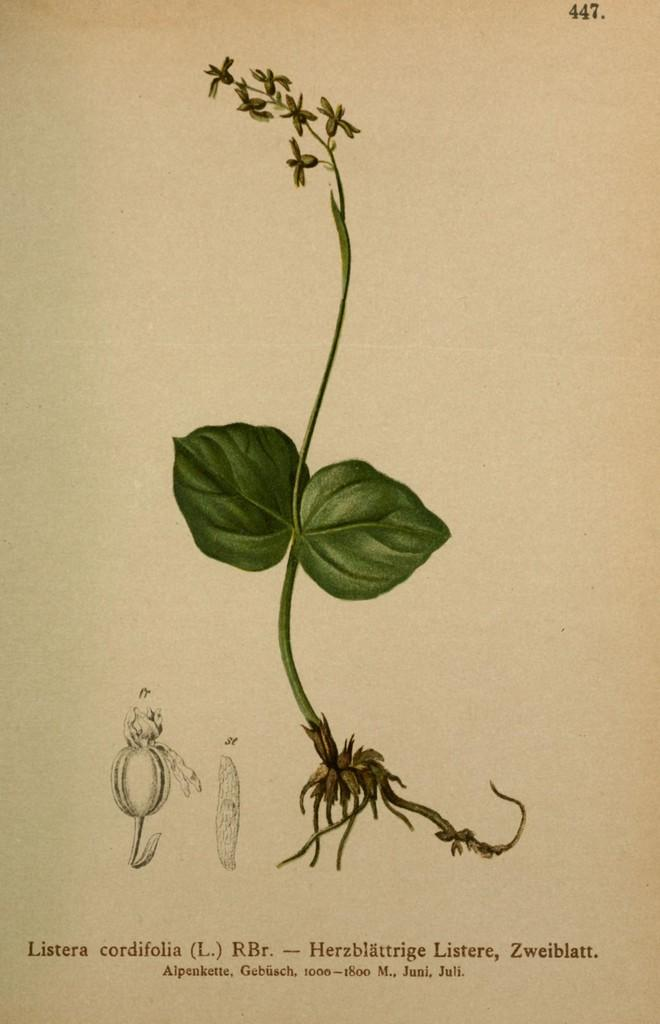What is the paper with information in the image used for? The paper with information in the image is likely used for conveying or recording data. What type of living organism is present in the image? There is a plant in the image. What part of the plant is visible in the image? Leaves are present in the image. What type of attraction can be seen in the image? There is no attraction present in the image; it features a paper with information and a plant with leaves. How does the plant behave in the image? The plant does not exhibit any specific behavior in the image; it is simply present with its leaves visible. 